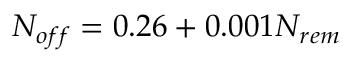Convert formula to latex. <formula><loc_0><loc_0><loc_500><loc_500>N _ { o f f } = 0 . 2 6 + 0 . 0 0 1 N _ { r e m }</formula> 